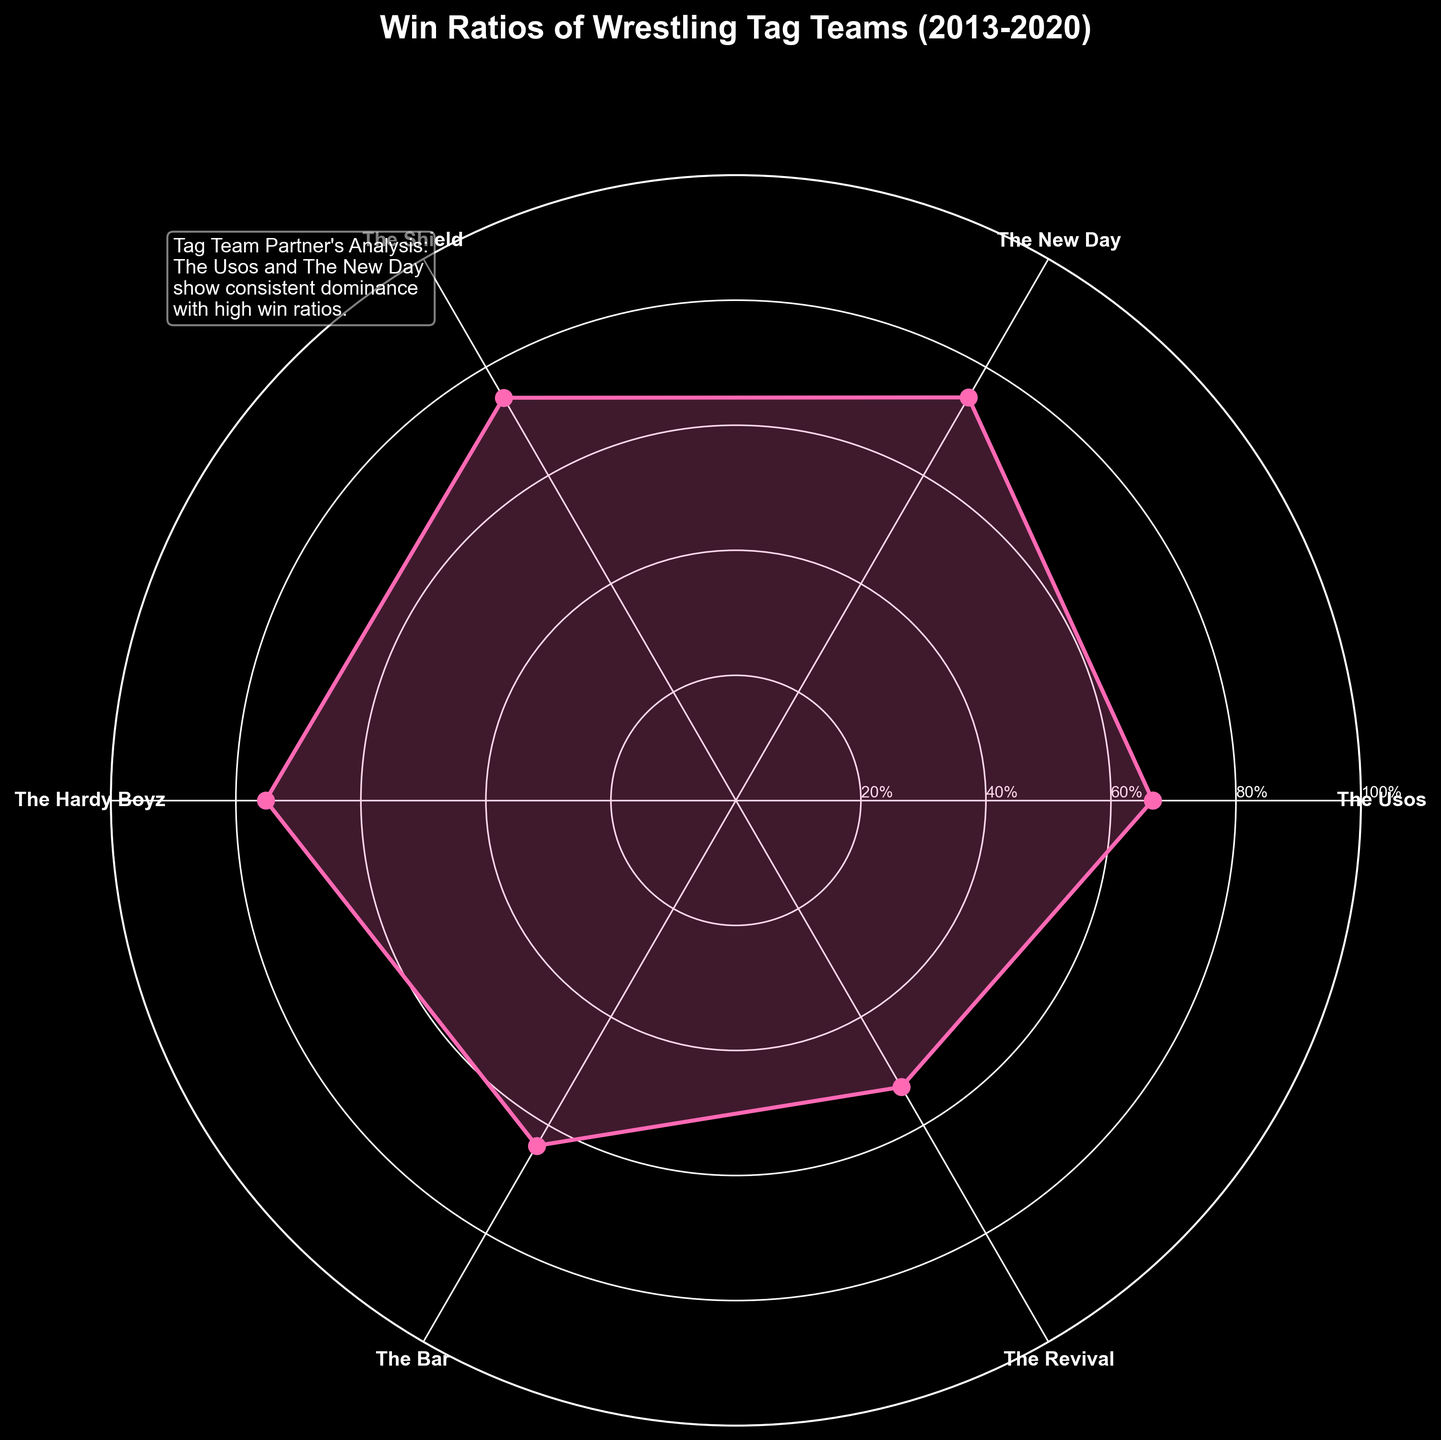Which tag team shows the highest win ratio in the plot? The plot indicates win ratios for various tag teams. Identify the highest point on the plot and check which team's label corresponds to this point.
Answer: The New Day Which tag team has the lowest win ratio? The plot indicates win ratios for various tag teams. Identify the lowest point on the plot and check which team's label corresponds to this point.
Answer: The Revival What is the title of the plot? The title is displayed at the top of the plot.
Answer: "Win Ratios of Wrestling Tag Teams (2013-2020)" Which tag teams have a win ratio of less than 0.5? Identify points on the plot below the 0.5 mark on the radial axis and check the corresponding labels for these points.
Answer: The Bar, The Revival Between The Usos and The Shield, which team has a higher win ratio? Compare the points corresponding to The Usos and The Shield on the plot and see which is further from the center.
Answer: The Usos What is the win ratio of The Hardy Boyz according to the plot? Find the point on the plot corresponding to The Hardy Boyz and read its value from the radial axis.
Answer: Approximately 0.75 How many teams have a win ratio greater than 0.7? Count the number of points on the plot that are above the 0.7 mark on the radial axis.
Answer: Three What is the general trend for the win ratios of the teams displayed? Observe the pattern formed by the points on the plot; most points are clustered around a specific value.
Answer: Most teams have a win ratio above 0.5 Which team has the second-highest win ratio? Identify the second-highest point from the center on the plot and find the corresponding team label.
Answer: The Usos What is the win ratio difference between The New Day and The Revival? Identify the points corresponding to The New Day and The Revival, read their values, and calculate the difference.
Answer: Approximately 0.45 